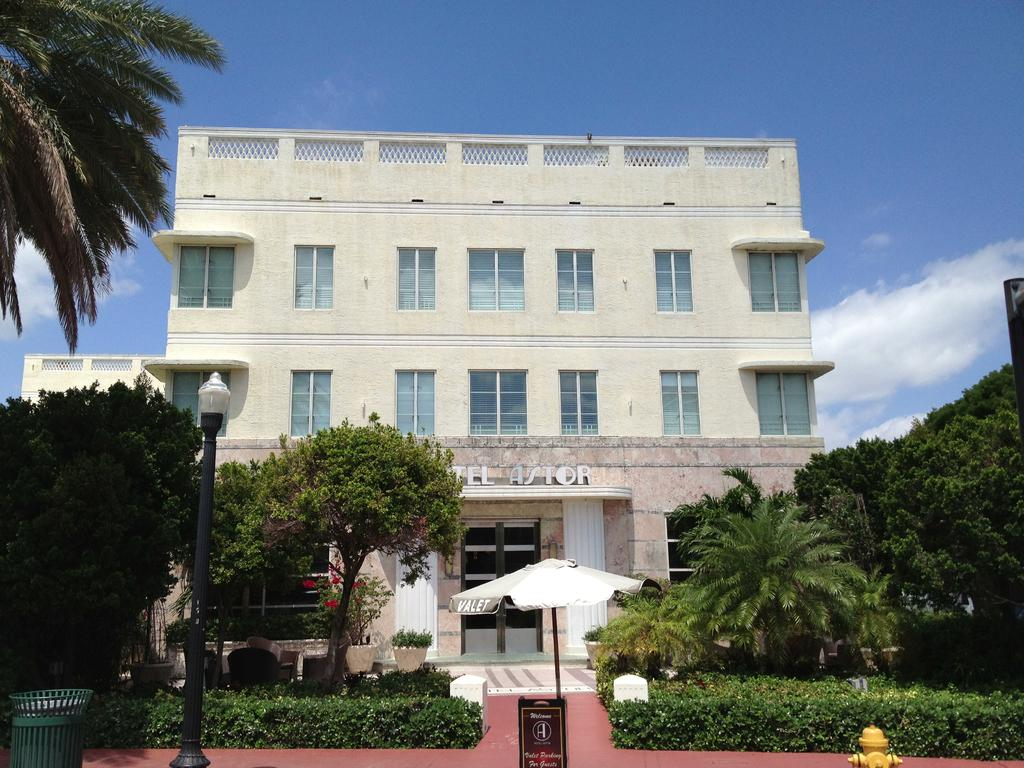Provide a one-sentence caption for the provided image. The facade and outside of a hotel called Astor. 